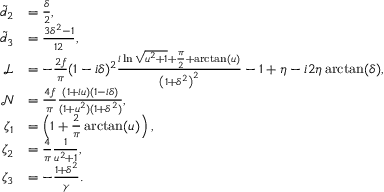<formula> <loc_0><loc_0><loc_500><loc_500>\begin{array} { r l } { \tilde { d } _ { 2 } } & { = \frac { \delta } { 2 } , } \\ { \tilde { d } _ { 3 } } & { = \frac { 3 \delta ^ { 2 } - 1 } { 1 2 } , } \\ { \mathcal { L } } & { = - \frac { 2 f } { \pi } ( 1 - i \delta ) ^ { 2 } \frac { i \ln \sqrt { u ^ { 2 } + 1 } + \frac { \pi } { 2 } + \arctan ( u ) } { \left ( 1 + \delta ^ { 2 } \right ) ^ { 2 } } - 1 + \eta - i 2 \eta \arctan ( \delta ) , } \\ { \mathcal { N } } & { = \frac { 4 f } { \pi } \frac { ( 1 + i u ) ( 1 - i \delta ) } { ( 1 + u ^ { 2 } ) ( 1 + \delta ^ { 2 } ) } , } \\ { \zeta _ { 1 } } & { = \left ( 1 + \frac { 2 } { \pi } \arctan ( u ) \right ) , } \\ { \zeta _ { 2 } } & { = \frac { 4 } { \pi } \frac { 1 } { u ^ { 2 } + 1 } , } \\ { \zeta _ { 3 } } & { = - \frac { 1 + \delta ^ { 2 } } { \gamma } . } \end{array}</formula> 